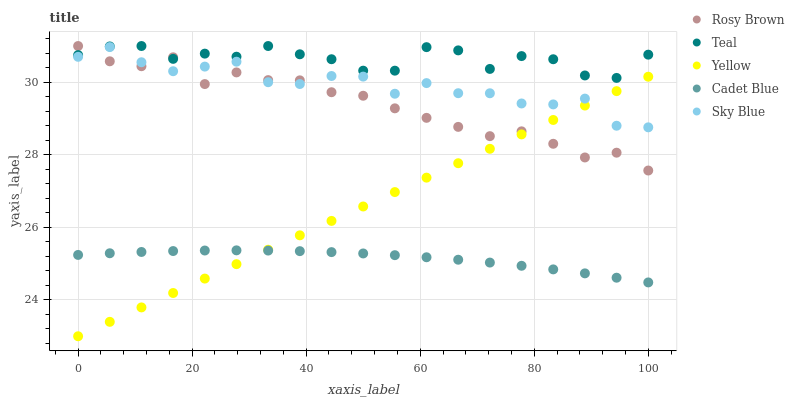Does Cadet Blue have the minimum area under the curve?
Answer yes or no. Yes. Does Teal have the maximum area under the curve?
Answer yes or no. Yes. Does Sky Blue have the minimum area under the curve?
Answer yes or no. No. Does Sky Blue have the maximum area under the curve?
Answer yes or no. No. Is Yellow the smoothest?
Answer yes or no. Yes. Is Teal the roughest?
Answer yes or no. Yes. Is Sky Blue the smoothest?
Answer yes or no. No. Is Sky Blue the roughest?
Answer yes or no. No. Does Yellow have the lowest value?
Answer yes or no. Yes. Does Sky Blue have the lowest value?
Answer yes or no. No. Does Teal have the highest value?
Answer yes or no. Yes. Does Sky Blue have the highest value?
Answer yes or no. No. Is Cadet Blue less than Teal?
Answer yes or no. Yes. Is Rosy Brown greater than Cadet Blue?
Answer yes or no. Yes. Does Sky Blue intersect Rosy Brown?
Answer yes or no. Yes. Is Sky Blue less than Rosy Brown?
Answer yes or no. No. Is Sky Blue greater than Rosy Brown?
Answer yes or no. No. Does Cadet Blue intersect Teal?
Answer yes or no. No. 